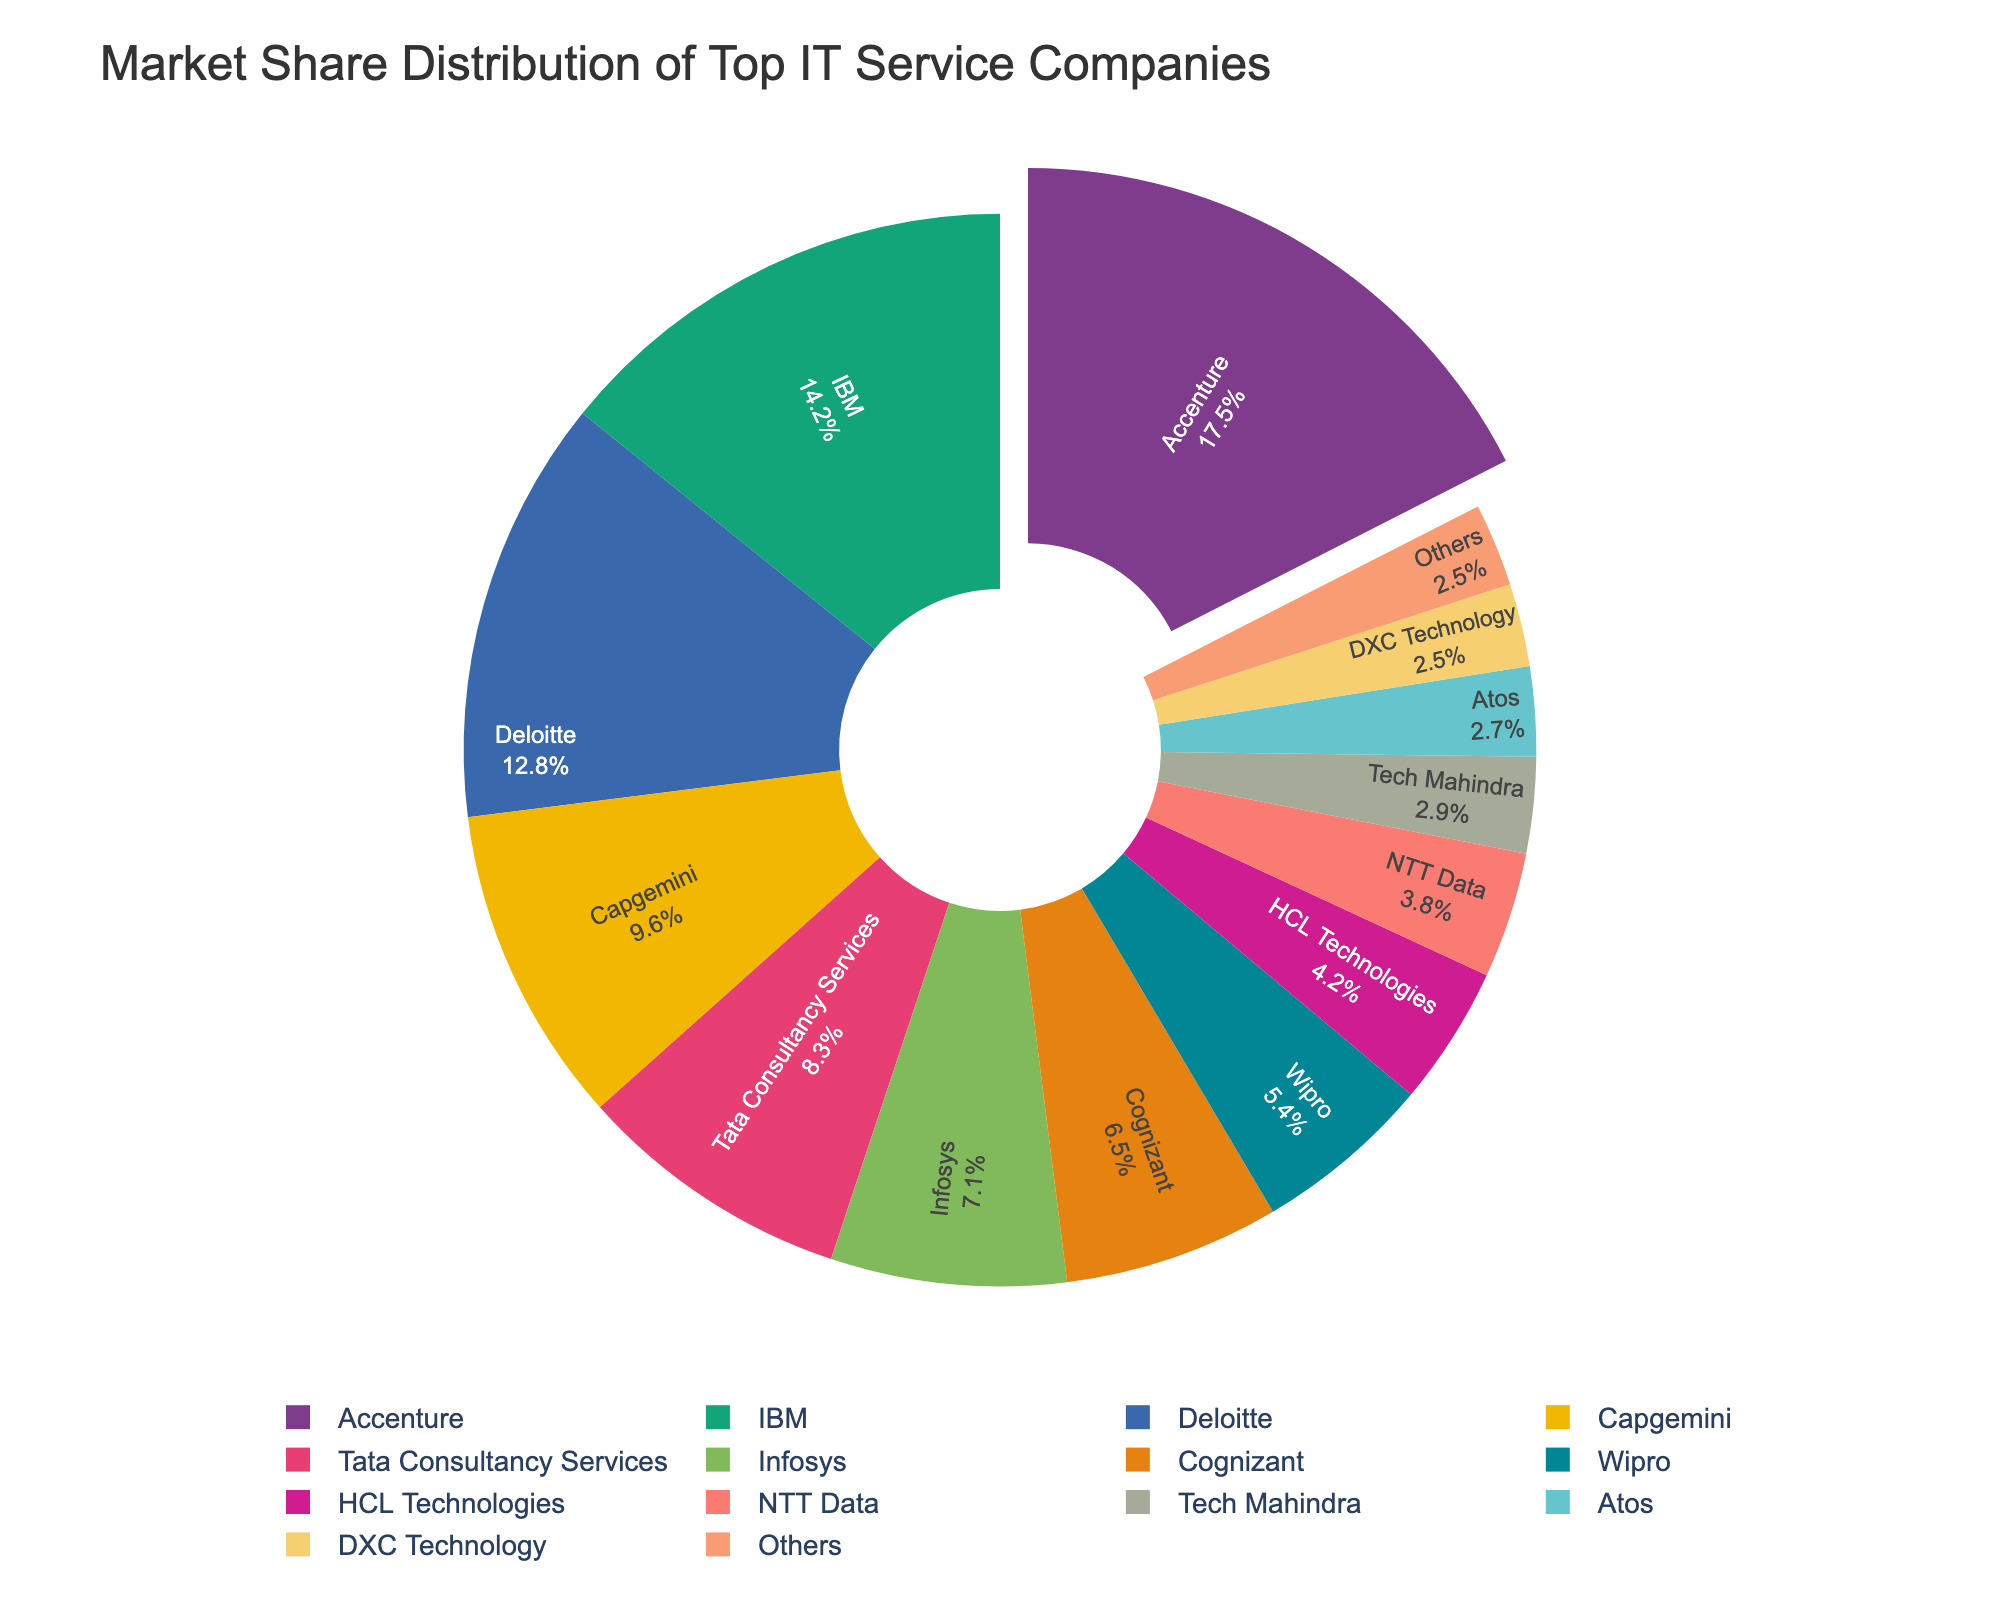Which company has the largest market share? By looking at the pie chart, the segment with the largest portion can be identified as having the largest market share. Accenture has the largest slice indicating the highest market share.
Answer: Accenture What is the percent difference in market share between IBM and Tata Consultancy Services? To find the percent difference between IBM and Tata Consultancy Services, subtract Tata's market share from IBM's, and then divide by IBM's market share. IBM's share is 14.2% and Tata's is 8.3%. So, (14.2% - 8.3%) / 14.2% ≈ 0.415 or 41.5%.
Answer: 41.5% What is the combined market share of Deloitte, Capgemini, and Cognizant? To find the combined market share, add the market shares of Deloitte, Capgemini, and Cognizant. Deloitte has 12.8%, Capgemini has 9.6%, and Cognizant has 6.5%. So, 12.8% + 9.6% + 6.5% = 28.9%.
Answer: 28.9% Which company has the smallest market share, and what is it? By examining the pie chart, the smallest segment corresponds to the company with the smallest market share. DXC Technology and 'Others' both have the smallest proportions at 2.5% each.
Answer: DXC Technology and Others, 2.5% How many companies have a market share greater than 10%? By looking at the chart, identify the companies with segments larger than 10%. Accenture, IBM, and Deloitte each have market shares greater than 10%.
Answer: 3 What is the difference in market share between the top company and the company with the median market share? To solve this, identify the top company (Accenture with 17.5%) and determine the company at the median position in the sorted list. The sorted list places Infosys (7.1%) in the median position. So, 17.5% - 7.1% = 10.4%.
Answer: 10.4% Which companies have similar market shares, and what are those shares? Identify companies with market shares that are very close by examining the pie chart. DXC Technology and Others both have a market share of 2.5%.
Answer: DXC Technology, Others, 2.5% What is the total market share of companies with less than 5%? Sum the market shares of all companies listed in the figure with less than 5%. The companies are HCL Technologies (4.2%), NTT Data (3.8%), Tech Mahindra (2.9%), Atos (2.7%), DXC Technology (2.5%), and Others (2.5%). The total is 4.2% + 3.8% + 2.9% + 2.7% + 2.5% + 2.5% = 18.6%.
Answer: 18.6% Which companies have market shares that sum up to 25.0%? To find companies whose market shares add up to 25%, group the values accordingly. One possible grouping is IBM (14.2%) and Infosys (7.1%) for a total of 21.3%, then add DXC Technology (2.5%), which brings the total close, but not exactly 25%. Another group is Capgemini (9.6%), Tata Consultancy Services (8.3%), and Wipro (5.4%), totaling to 23.3%. No exact match for 25.0%, but Capgemini, Tata Consultancy Services, and Wipro sum up closely.
Answer: No exact match, closest: Capgemini, Tata Consultancy Services, Wipro, 23.3% Which company slice is visually the second largest, and what is its market share? By looking at the size of the pie slices, identify the second largest segment which belongs to IBM with a market share of 14.2%.
Answer: IBM, 14.2% 